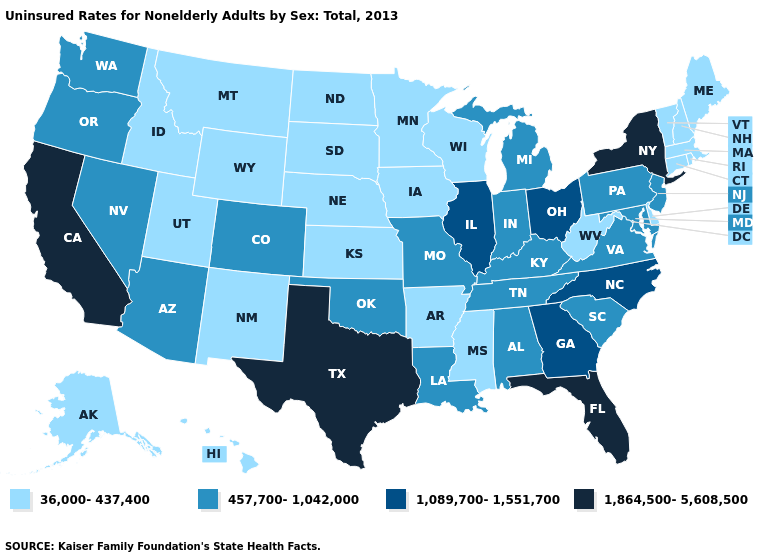What is the value of Nevada?
Give a very brief answer. 457,700-1,042,000. What is the highest value in the Northeast ?
Write a very short answer. 1,864,500-5,608,500. Among the states that border Pennsylvania , which have the lowest value?
Write a very short answer. Delaware, West Virginia. Among the states that border West Virginia , does Ohio have the highest value?
Be succinct. Yes. Name the states that have a value in the range 457,700-1,042,000?
Give a very brief answer. Alabama, Arizona, Colorado, Indiana, Kentucky, Louisiana, Maryland, Michigan, Missouri, Nevada, New Jersey, Oklahoma, Oregon, Pennsylvania, South Carolina, Tennessee, Virginia, Washington. Which states have the lowest value in the USA?
Answer briefly. Alaska, Arkansas, Connecticut, Delaware, Hawaii, Idaho, Iowa, Kansas, Maine, Massachusetts, Minnesota, Mississippi, Montana, Nebraska, New Hampshire, New Mexico, North Dakota, Rhode Island, South Dakota, Utah, Vermont, West Virginia, Wisconsin, Wyoming. What is the value of Delaware?
Be succinct. 36,000-437,400. Name the states that have a value in the range 1,864,500-5,608,500?
Concise answer only. California, Florida, New York, Texas. How many symbols are there in the legend?
Quick response, please. 4. What is the value of Connecticut?
Write a very short answer. 36,000-437,400. What is the value of Idaho?
Answer briefly. 36,000-437,400. Name the states that have a value in the range 457,700-1,042,000?
Short answer required. Alabama, Arizona, Colorado, Indiana, Kentucky, Louisiana, Maryland, Michigan, Missouri, Nevada, New Jersey, Oklahoma, Oregon, Pennsylvania, South Carolina, Tennessee, Virginia, Washington. Does North Dakota have the lowest value in the MidWest?
Short answer required. Yes. Name the states that have a value in the range 36,000-437,400?
Write a very short answer. Alaska, Arkansas, Connecticut, Delaware, Hawaii, Idaho, Iowa, Kansas, Maine, Massachusetts, Minnesota, Mississippi, Montana, Nebraska, New Hampshire, New Mexico, North Dakota, Rhode Island, South Dakota, Utah, Vermont, West Virginia, Wisconsin, Wyoming. How many symbols are there in the legend?
Give a very brief answer. 4. 